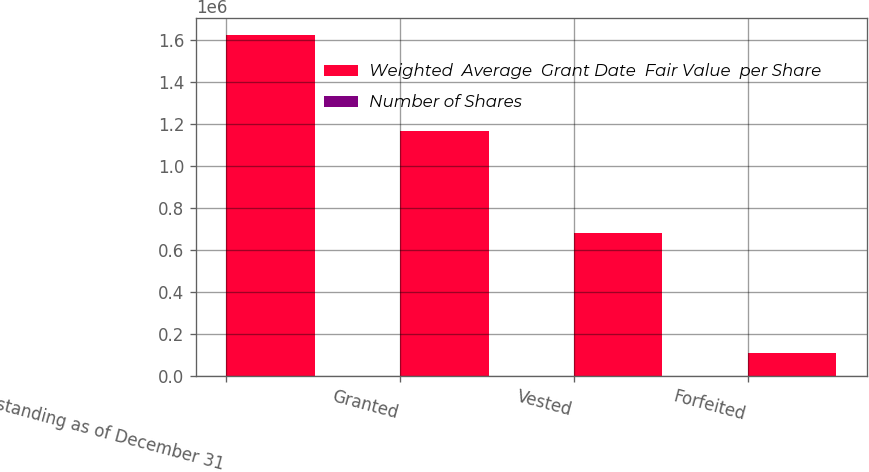Convert chart. <chart><loc_0><loc_0><loc_500><loc_500><stacked_bar_chart><ecel><fcel>Outstanding as of December 31<fcel>Granted<fcel>Vested<fcel>Forfeited<nl><fcel>Weighted  Average  Grant Date  Fair Value  per Share<fcel>1.62454e+06<fcel>1.16924e+06<fcel>683262<fcel>107519<nl><fcel>Number of Shares<fcel>65.24<fcel>59.73<fcel>70.5<fcel>66.9<nl></chart> 